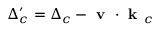Convert formula to latex. <formula><loc_0><loc_0><loc_500><loc_500>\Delta _ { c } ^ { \prime } = \Delta _ { c } - v k _ { c }</formula> 